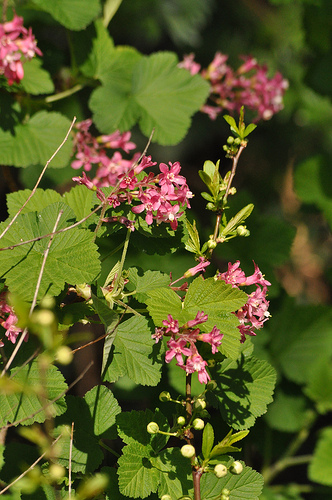<image>
Is there a flowers in front of the leaves? Yes. The flowers is positioned in front of the leaves, appearing closer to the camera viewpoint. 